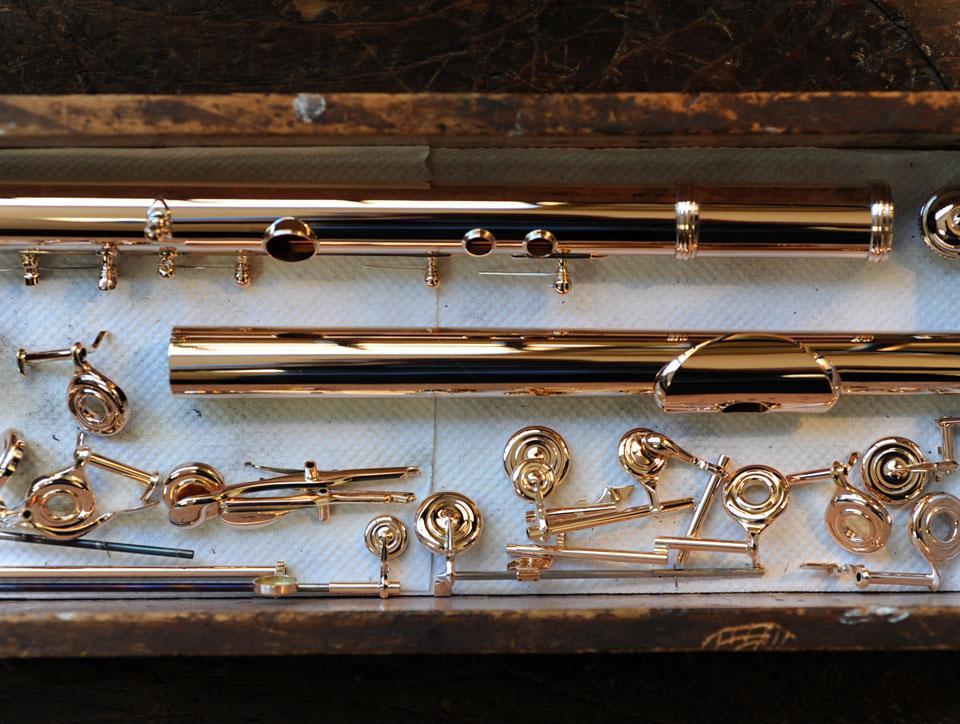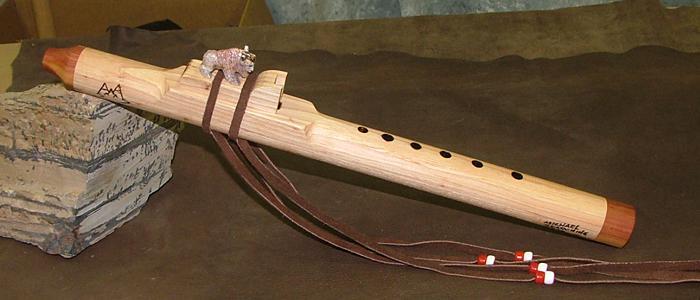The first image is the image on the left, the second image is the image on the right. Evaluate the accuracy of this statement regarding the images: "IN at least one image there is a flute end sitting on a squarded rock.". Is it true? Answer yes or no. Yes. The first image is the image on the left, the second image is the image on the right. Evaluate the accuracy of this statement regarding the images: "An image shows a wooden flute with its mouthpiece end propped up and with a carved animal figure above a tassel tie.". Is it true? Answer yes or no. Yes. 